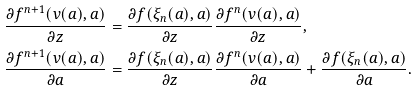<formula> <loc_0><loc_0><loc_500><loc_500>\frac { \partial f ^ { n + 1 } ( v ( a ) , a ) } { \partial z } & = \frac { \partial f ( \xi _ { n } ( a ) , a ) } { \partial z } \frac { \partial f ^ { n } ( v ( a ) , a ) } { \partial z } , \\ \frac { \partial f ^ { n + 1 } ( v ( a ) , a ) } { \partial a } & = \frac { \partial f ( \xi _ { n } ( a ) , a ) } { \partial z } \frac { \partial f ^ { n } ( v ( a ) , a ) } { \partial a } + \frac { \partial f ( \xi _ { n } ( a ) , a ) } { \partial a } .</formula> 